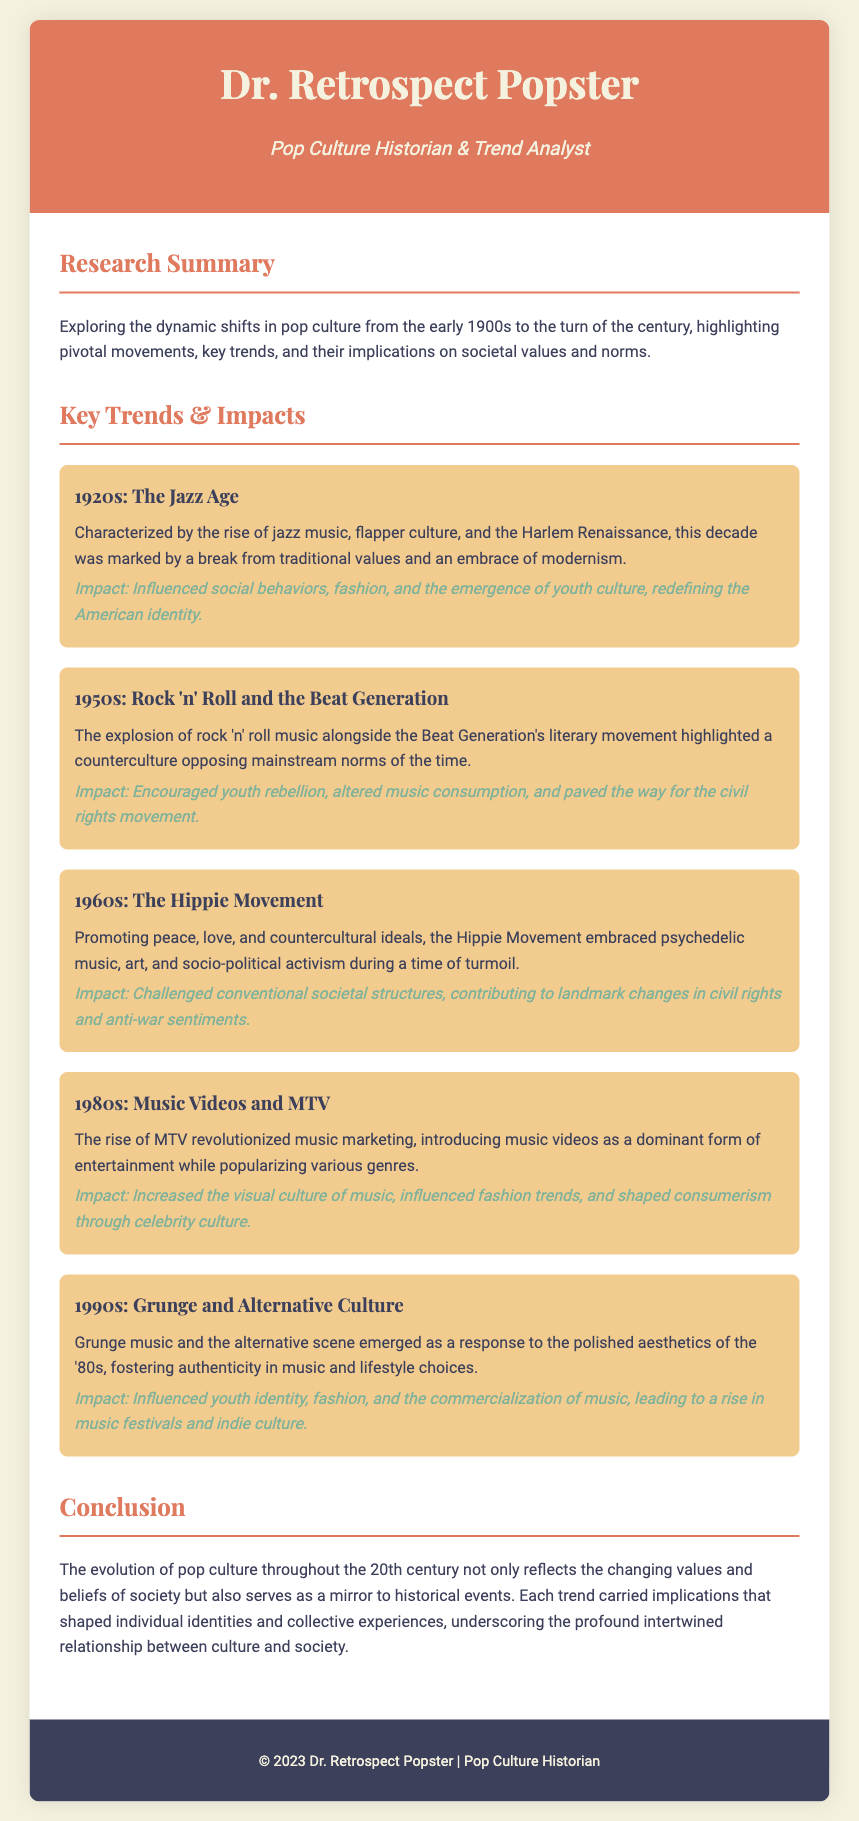What is the main focus of the research summary? The research summary focuses on the dynamic shifts in pop culture from the early 1900s to the turn of the century, highlighting pivotal movements, key trends, and their implications on societal values and norms.
Answer: Dynamic shifts in pop culture What decade is associated with the Jazz Age? The document specifies that the 1920s is characterized as the Jazz Age.
Answer: 1920s Which musical genre emerged during the 1950s? The document mentions rock 'n' roll as the prominent genre during the 1950s.
Answer: Rock 'n' roll What cultural movement is described in the 1960s section? The document describes the Hippie Movement as a cultural shift during the 1960s.
Answer: Hippie Movement How did MTV influence culture in the 1980s? MTV revolutionized music marketing by introducing music videos as a dominant form of entertainment.
Answer: Music videos What impact did grunge music have in the 1990s? Grunge music influenced youth identity, fashion, and the commercialization of music.
Answer: Youth identity What is the title of the document's main author? The author's title is Pop Culture Historian & Trend Analyst.
Answer: Pop Culture Historian & Trend Analyst How are societal values reflected in pop culture evolution? The conclusion states that the evolution of pop culture reflects the changing values and beliefs of society.
Answer: Changing values and beliefs What year does the copyright statement indicate? The copyright statement indicates the year 2023.
Answer: 2023 